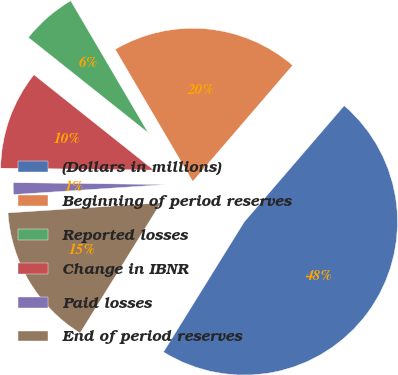<chart> <loc_0><loc_0><loc_500><loc_500><pie_chart><fcel>(Dollars in millions)<fcel>Beginning of period reserves<fcel>Reported losses<fcel>Change in IBNR<fcel>Paid losses<fcel>End of period reserves<nl><fcel>47.53%<fcel>19.75%<fcel>5.86%<fcel>10.49%<fcel>1.24%<fcel>15.12%<nl></chart> 